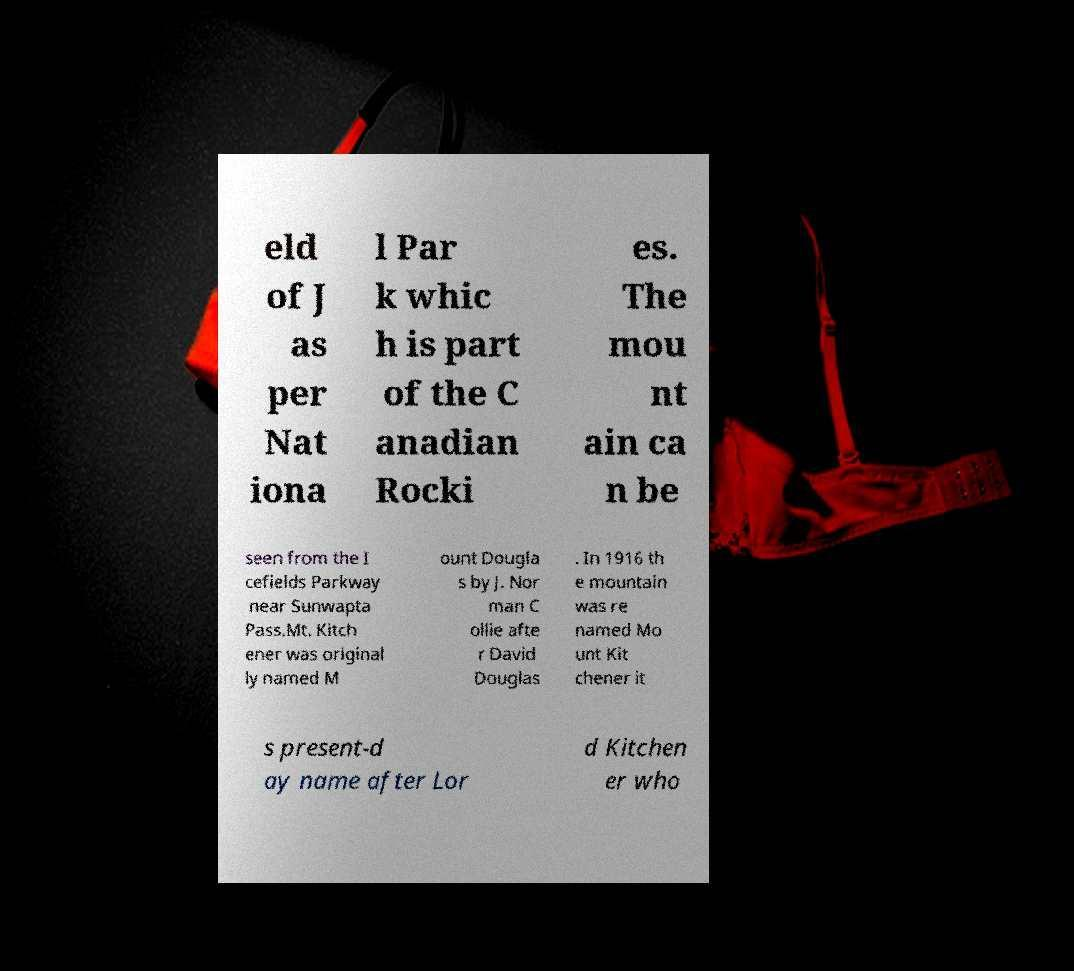What messages or text are displayed in this image? I need them in a readable, typed format. eld of J as per Nat iona l Par k whic h is part of the C anadian Rocki es. The mou nt ain ca n be seen from the I cefields Parkway near Sunwapta Pass.Mt. Kitch ener was original ly named M ount Dougla s by J. Nor man C ollie afte r David Douglas . In 1916 th e mountain was re named Mo unt Kit chener it s present-d ay name after Lor d Kitchen er who 